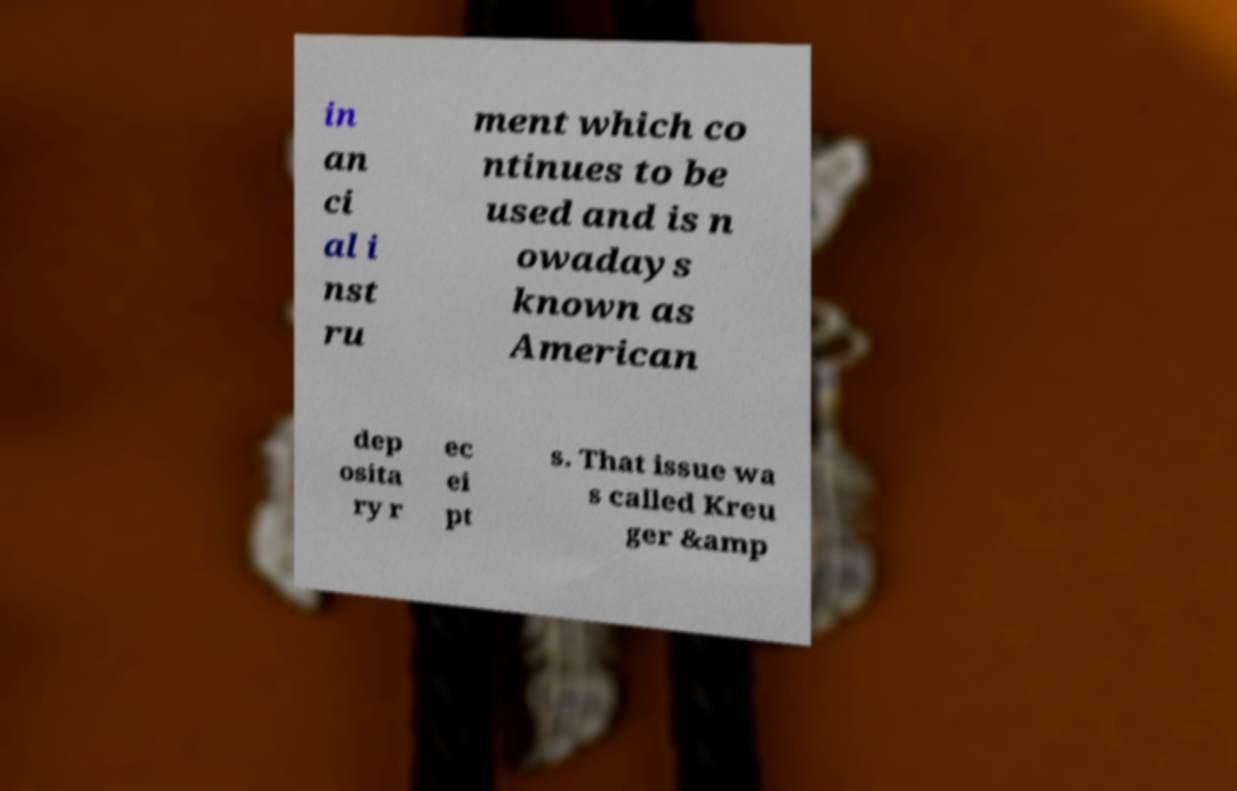Please identify and transcribe the text found in this image. in an ci al i nst ru ment which co ntinues to be used and is n owadays known as American dep osita ry r ec ei pt s. That issue wa s called Kreu ger &amp 